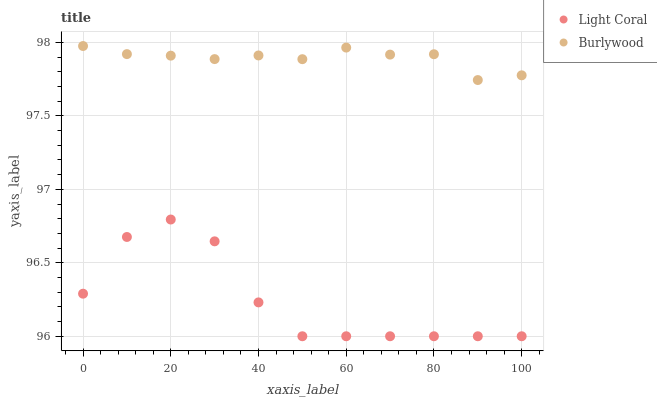Does Light Coral have the minimum area under the curve?
Answer yes or no. Yes. Does Burlywood have the maximum area under the curve?
Answer yes or no. Yes. Does Burlywood have the minimum area under the curve?
Answer yes or no. No. Is Burlywood the smoothest?
Answer yes or no. Yes. Is Light Coral the roughest?
Answer yes or no. Yes. Is Burlywood the roughest?
Answer yes or no. No. Does Light Coral have the lowest value?
Answer yes or no. Yes. Does Burlywood have the lowest value?
Answer yes or no. No. Does Burlywood have the highest value?
Answer yes or no. Yes. Is Light Coral less than Burlywood?
Answer yes or no. Yes. Is Burlywood greater than Light Coral?
Answer yes or no. Yes. Does Light Coral intersect Burlywood?
Answer yes or no. No. 